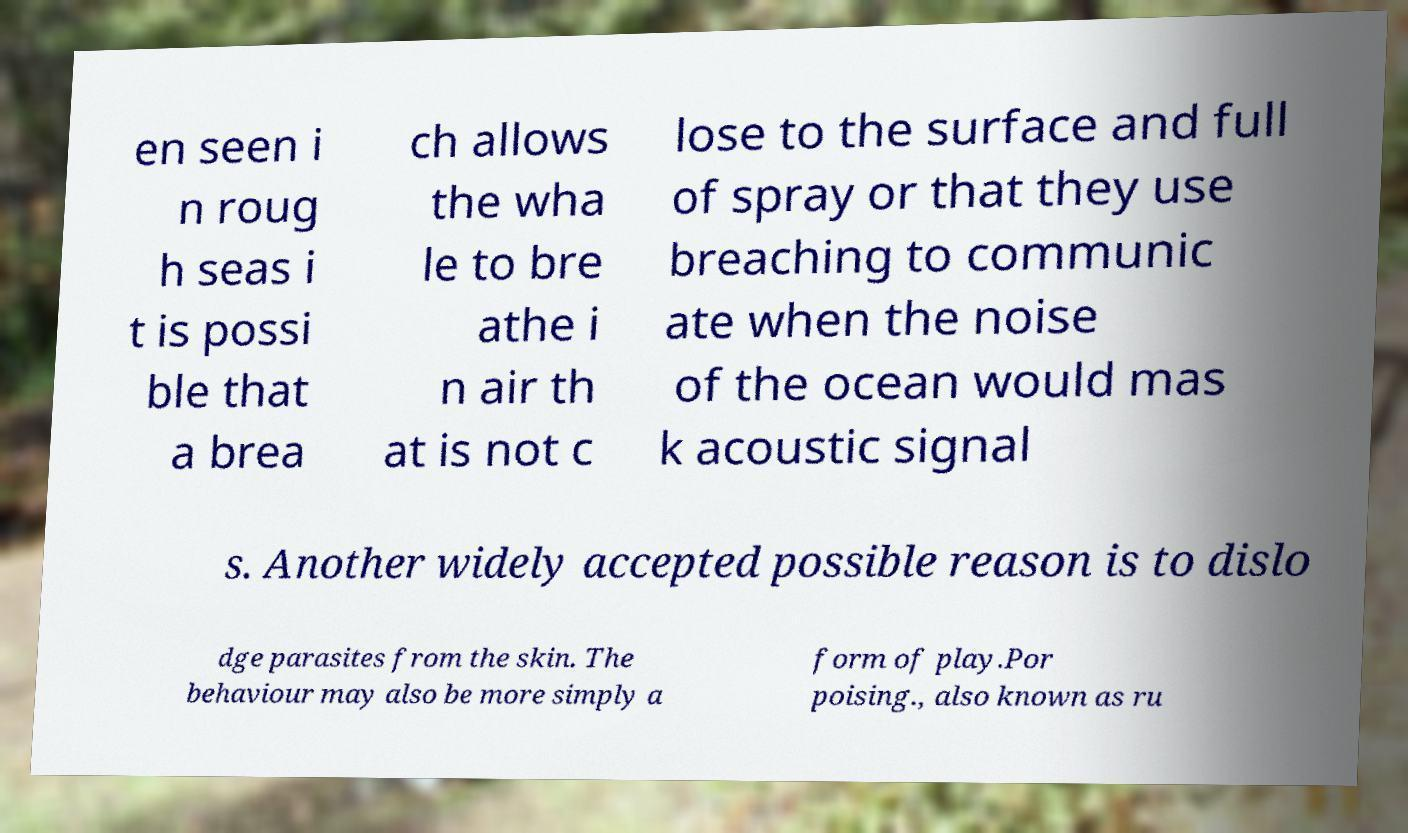Could you assist in decoding the text presented in this image and type it out clearly? en seen i n roug h seas i t is possi ble that a brea ch allows the wha le to bre athe i n air th at is not c lose to the surface and full of spray or that they use breaching to communic ate when the noise of the ocean would mas k acoustic signal s. Another widely accepted possible reason is to dislo dge parasites from the skin. The behaviour may also be more simply a form of play.Por poising., also known as ru 